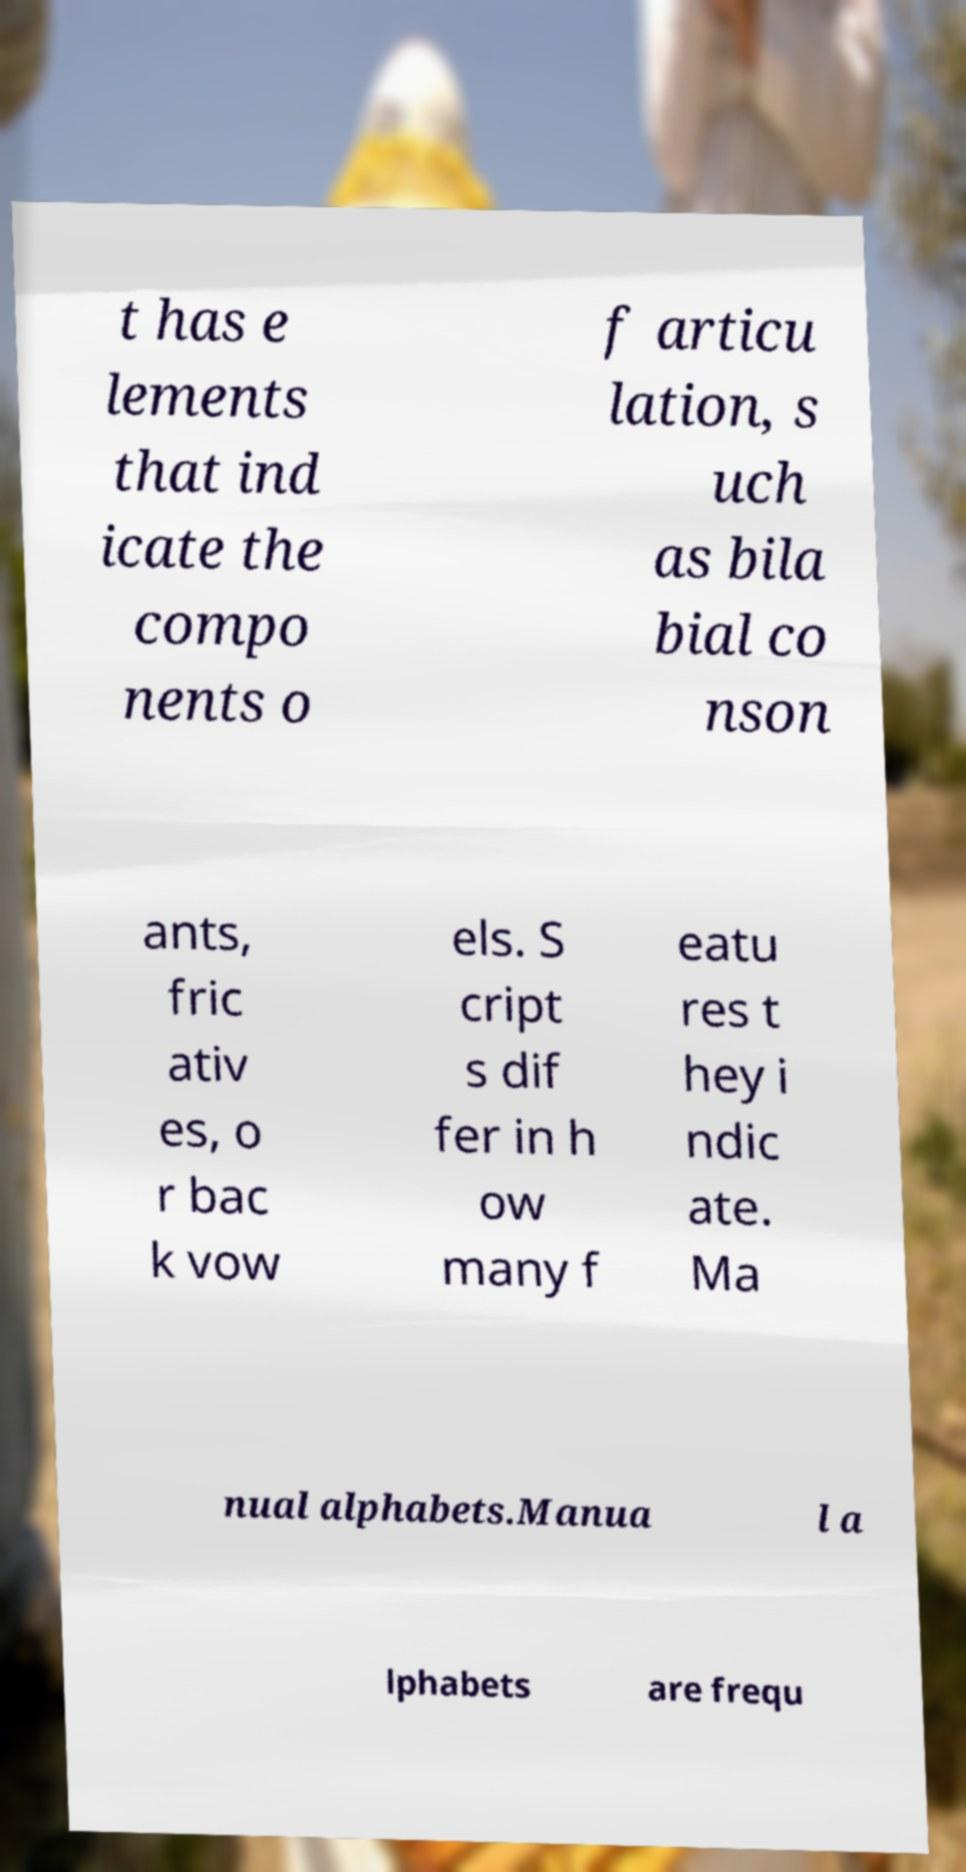There's text embedded in this image that I need extracted. Can you transcribe it verbatim? t has e lements that ind icate the compo nents o f articu lation, s uch as bila bial co nson ants, fric ativ es, o r bac k vow els. S cript s dif fer in h ow many f eatu res t hey i ndic ate. Ma nual alphabets.Manua l a lphabets are frequ 